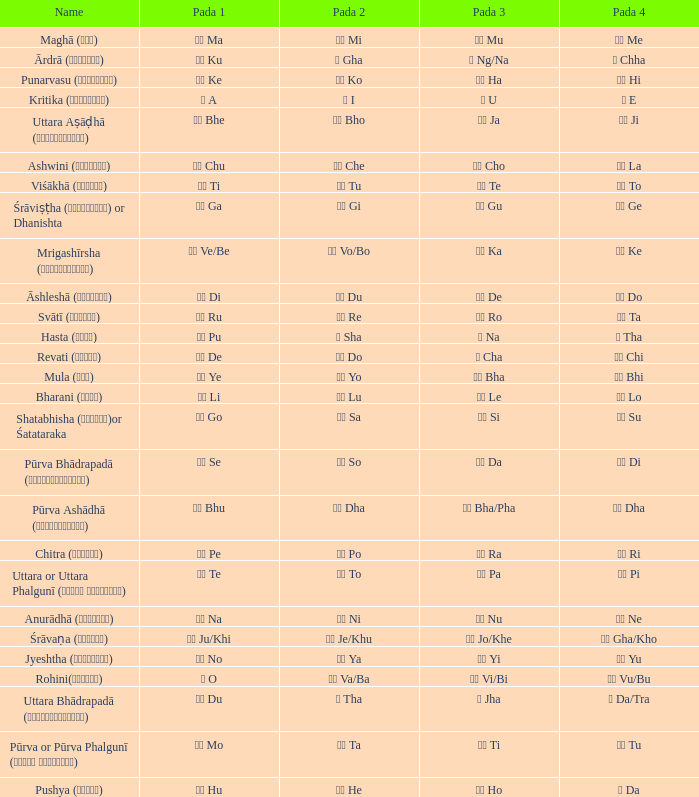Which Pada 3 has a Pada 1 of टे te? पा Pa. 